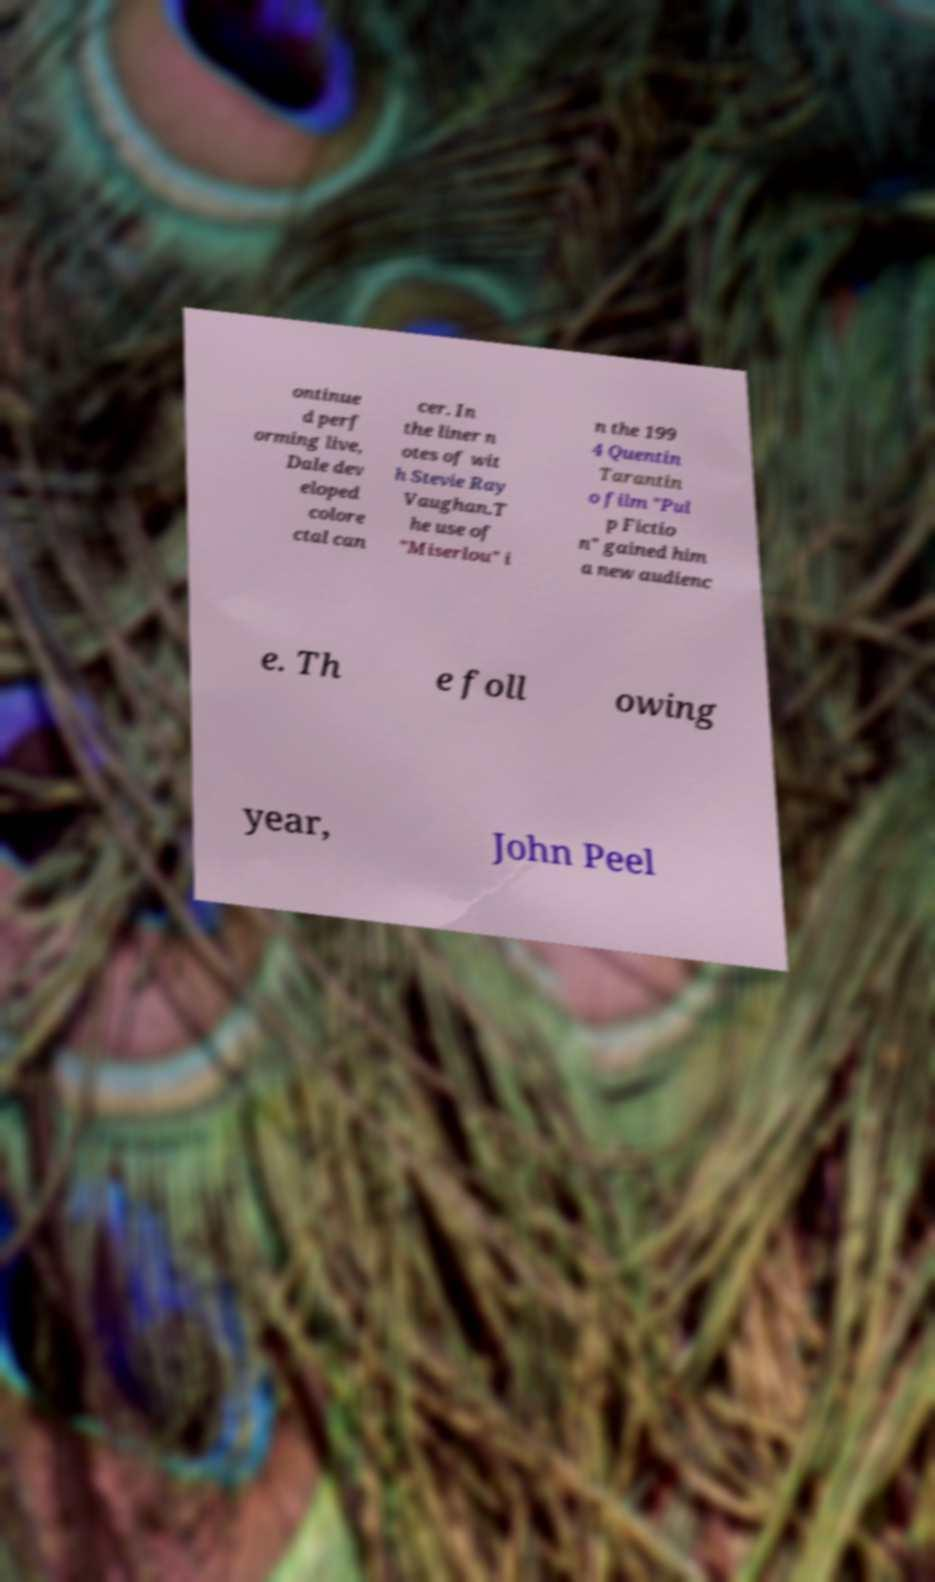Could you assist in decoding the text presented in this image and type it out clearly? ontinue d perf orming live, Dale dev eloped colore ctal can cer. In the liner n otes of wit h Stevie Ray Vaughan.T he use of "Miserlou" i n the 199 4 Quentin Tarantin o film "Pul p Fictio n" gained him a new audienc e. Th e foll owing year, John Peel 